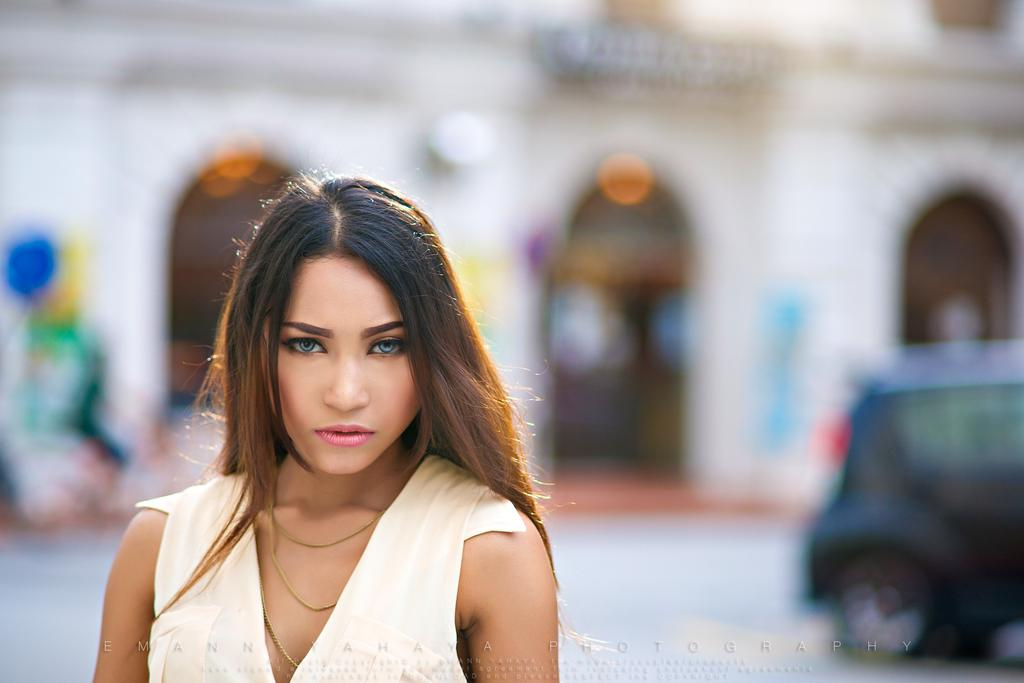Who is the main subject in the image? There is a lady in the image. What can be seen in the background of the image? There is a building and lights visible in the background. What else is present in the background of the image? There is a vehicle on the road in the background. What information is provided at the bottom of the image? There is some text at the bottom of the image. What type of hydrant is visible in the image? There is no hydrant present in the image. What mark does the lady leave on the building in the image? The lady does not leave any mark on the building in the image. 